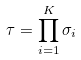<formula> <loc_0><loc_0><loc_500><loc_500>\tau = \prod _ { i = 1 } ^ { K } \sigma _ { i }</formula> 